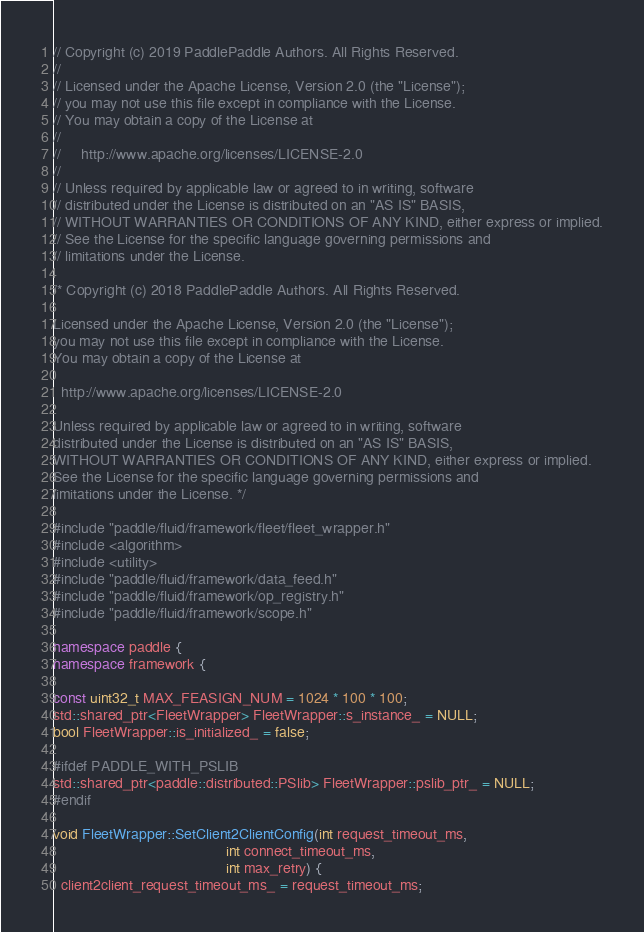Convert code to text. <code><loc_0><loc_0><loc_500><loc_500><_C++_>// Copyright (c) 2019 PaddlePaddle Authors. All Rights Reserved.
//
// Licensed under the Apache License, Version 2.0 (the "License");
// you may not use this file except in compliance with the License.
// You may obtain a copy of the License at
//
//     http://www.apache.org/licenses/LICENSE-2.0
//
// Unless required by applicable law or agreed to in writing, software
// distributed under the License is distributed on an "AS IS" BASIS,
// WITHOUT WARRANTIES OR CONDITIONS OF ANY KIND, either express or implied.
// See the License for the specific language governing permissions and
// limitations under the License.

/* Copyright (c) 2018 PaddlePaddle Authors. All Rights Reserved.

Licensed under the Apache License, Version 2.0 (the "License");
you may not use this file except in compliance with the License.
You may obtain a copy of the License at

  http://www.apache.org/licenses/LICENSE-2.0

Unless required by applicable law or agreed to in writing, software
distributed under the License is distributed on an "AS IS" BASIS,
WITHOUT WARRANTIES OR CONDITIONS OF ANY KIND, either express or implied.
See the License for the specific language governing permissions and
limitations under the License. */

#include "paddle/fluid/framework/fleet/fleet_wrapper.h"
#include <algorithm>
#include <utility>
#include "paddle/fluid/framework/data_feed.h"
#include "paddle/fluid/framework/op_registry.h"
#include "paddle/fluid/framework/scope.h"

namespace paddle {
namespace framework {

const uint32_t MAX_FEASIGN_NUM = 1024 * 100 * 100;
std::shared_ptr<FleetWrapper> FleetWrapper::s_instance_ = NULL;
bool FleetWrapper::is_initialized_ = false;

#ifdef PADDLE_WITH_PSLIB
std::shared_ptr<paddle::distributed::PSlib> FleetWrapper::pslib_ptr_ = NULL;
#endif

void FleetWrapper::SetClient2ClientConfig(int request_timeout_ms,
                                          int connect_timeout_ms,
                                          int max_retry) {
  client2client_request_timeout_ms_ = request_timeout_ms;</code> 